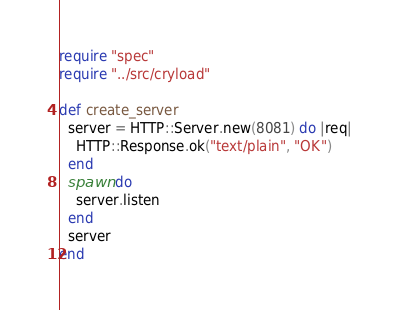Convert code to text. <code><loc_0><loc_0><loc_500><loc_500><_Crystal_>require "spec"
require "../src/cryload"

def create_server
  server = HTTP::Server.new(8081) do |req|
    HTTP::Response.ok("text/plain", "OK")
  end
  spawn do
    server.listen
  end
  server
end
</code> 